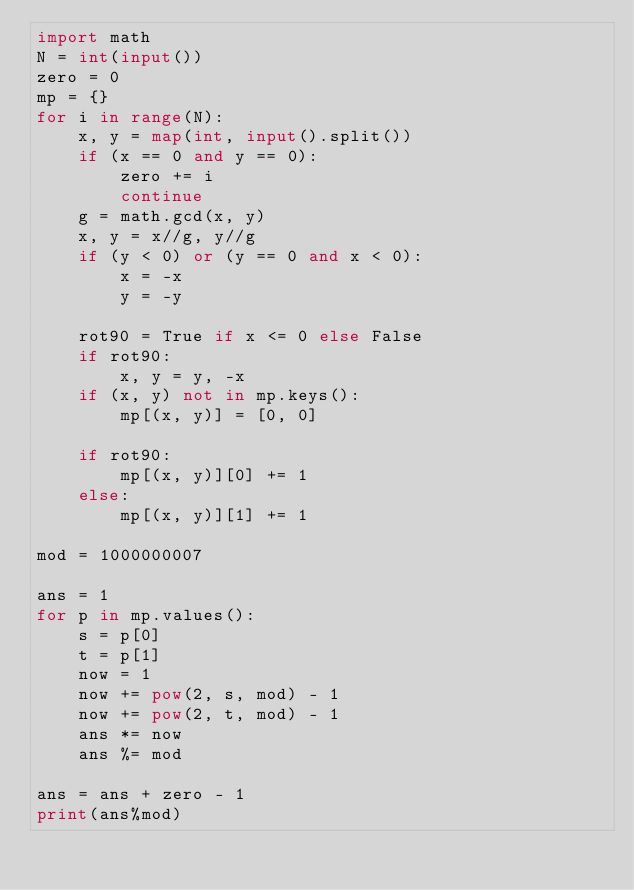Convert code to text. <code><loc_0><loc_0><loc_500><loc_500><_Python_>import math
N = int(input())
zero = 0
mp = {}
for i in range(N):
    x, y = map(int, input().split())
    if (x == 0 and y == 0):
        zero += i
        continue
    g = math.gcd(x, y)
    x, y = x//g, y//g
    if (y < 0) or (y == 0 and x < 0):
        x = -x
        y = -y

    rot90 = True if x <= 0 else False
    if rot90:
        x, y = y, -x
    if (x, y) not in mp.keys():
        mp[(x, y)] = [0, 0]

    if rot90:
        mp[(x, y)][0] += 1
    else:
        mp[(x, y)][1] += 1

mod = 1000000007

ans = 1
for p in mp.values():
    s = p[0]
    t = p[1]
    now = 1
    now += pow(2, s, mod) - 1
    now += pow(2, t, mod) - 1
    ans *= now
    ans %= mod

ans = ans + zero - 1
print(ans%mod)
</code> 